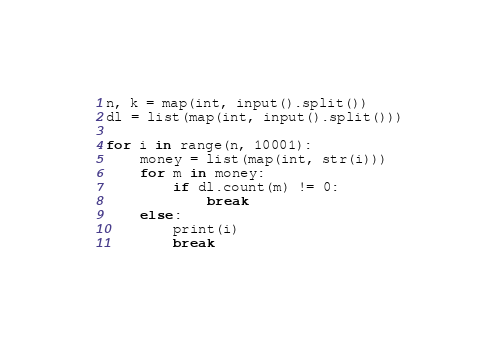Convert code to text. <code><loc_0><loc_0><loc_500><loc_500><_Python_>n, k = map(int, input().split())
dl = list(map(int, input().split()))

for i in range(n, 10001):
    money = list(map(int, str(i)))
    for m in money:
        if dl.count(m) != 0:
            break
    else:
        print(i)
        break
</code> 